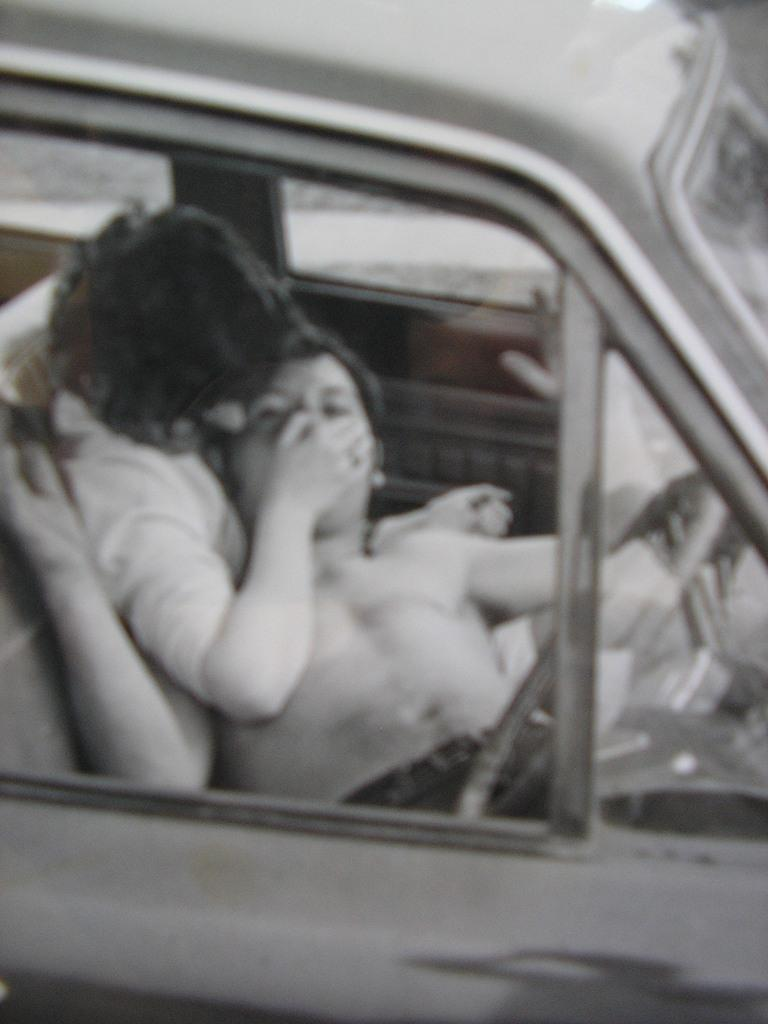How many people are in the image? There are two persons in the image. Where are the two persons located? The two persons are inside a car. What type of waves can be seen crashing on the shore in the image? There are no waves or shore visible in the image; it features two persons inside a car. 